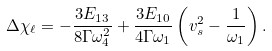Convert formula to latex. <formula><loc_0><loc_0><loc_500><loc_500>\Delta \chi _ { \ell } = - \frac { 3 E _ { 1 3 } } { 8 \Gamma \omega _ { 4 } ^ { 2 } } + \frac { 3 E _ { 1 0 } } { 4 \Gamma \omega _ { 1 } } \left ( v _ { s } ^ { 2 } - \frac { 1 } { \omega _ { 1 } } \right ) .</formula> 